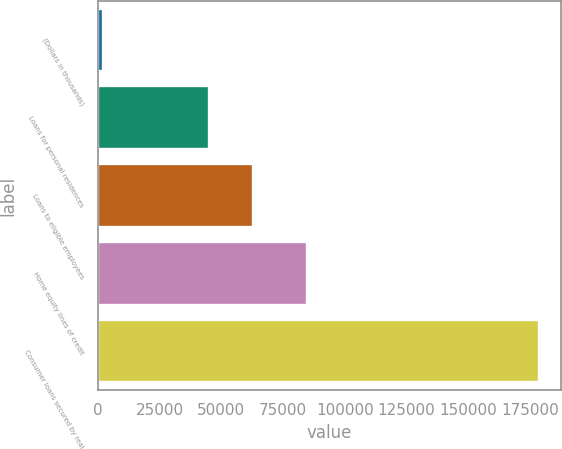Convert chart to OTSL. <chart><loc_0><loc_0><loc_500><loc_500><bar_chart><fcel>(Dollars in thousands)<fcel>Loans for personal residences<fcel>Loans to eligible employees<fcel>Home equity lines of credit<fcel>Consumer loans secured by real<nl><fcel>2007<fcel>45061<fcel>62742.6<fcel>84796<fcel>178823<nl></chart> 